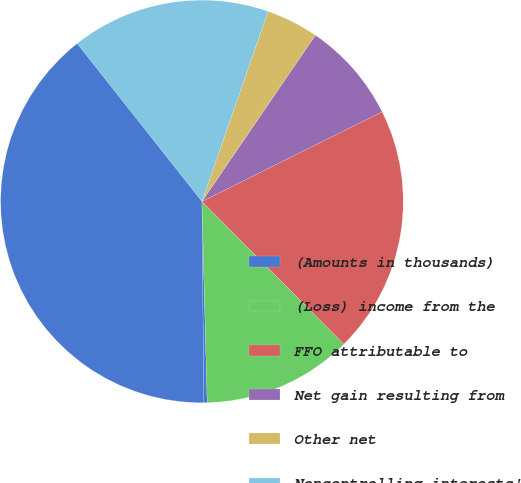Convert chart to OTSL. <chart><loc_0><loc_0><loc_500><loc_500><pie_chart><fcel>(Amounts in thousands)<fcel>(Loss) income from the<fcel>FFO attributable to<fcel>Net gain resulting from<fcel>Other net<fcel>Noncontrolling interests'<fcel>Items that affect<nl><fcel>0.27%<fcel>12.04%<fcel>19.89%<fcel>8.12%<fcel>4.2%<fcel>15.97%<fcel>39.51%<nl></chart> 